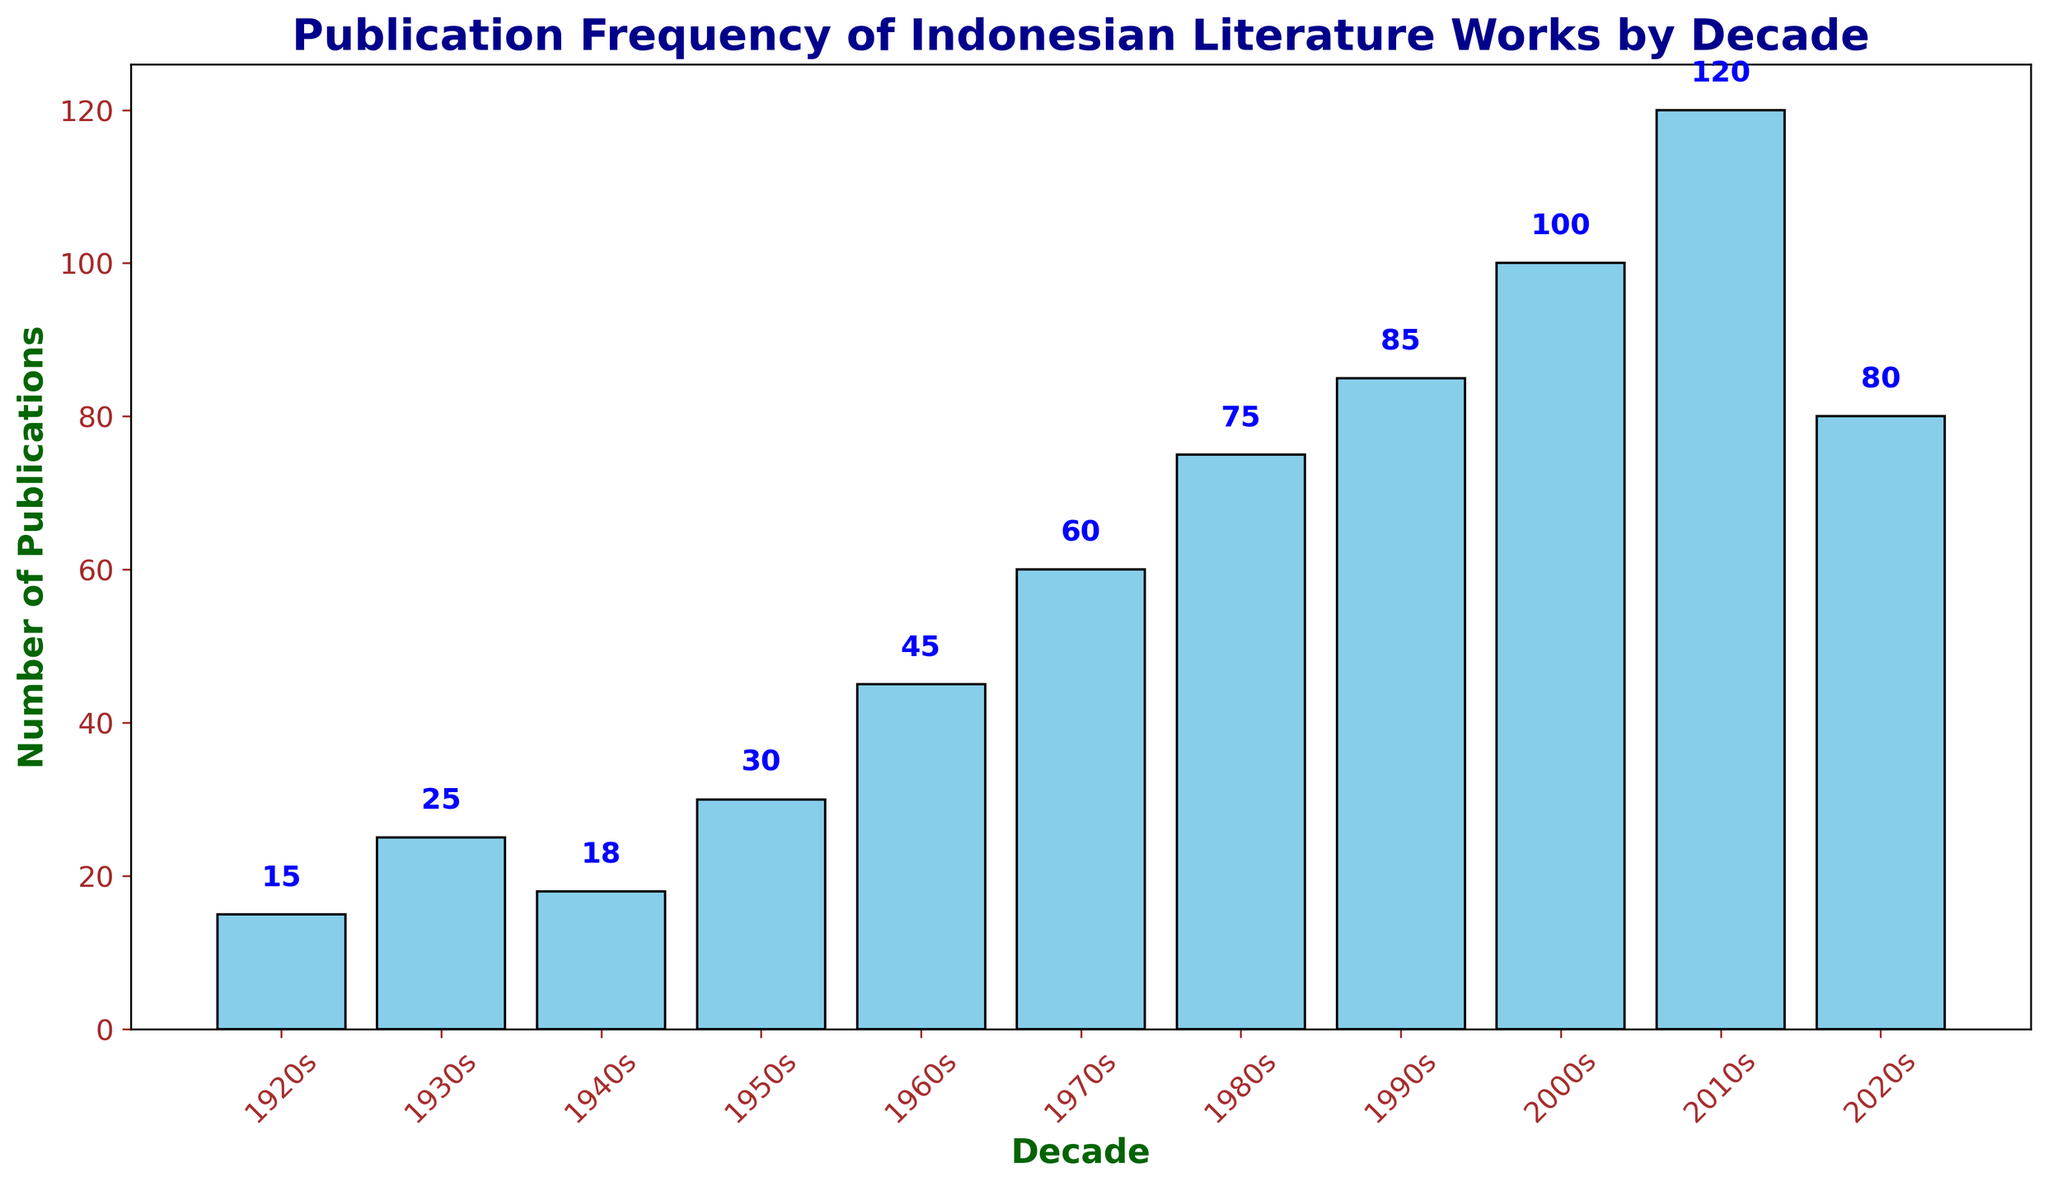What's the decade with the highest number of publications? The bar with the highest height represents the decade with the most publications, which is the 2010s at 120 publications.
Answer: 2010s Which decade experienced the greatest growth in the number of publications compared to the previous decade? By comparing the heights of the bars, the 2000s increased from 85 (1990s) to 100, and the 2010s increased from 100 (2000s) to 120. The 2000s decade had the greatest growth of 20 publications.
Answer: 2010s What is the average number of publications per decade? Summing up the number of publications from all decades and dividing by the number of decades (11). (15 + 25 + 18 + 30 + 45 + 60 + 75 + 85 + 100 + 120 + 80) / 11 = 65.45
Answer: 65.45 What is the difference in the number of publications between the 1920s and the 2020s? Subtract the number of publications in the 1920s (15) from the number in the 2020s (80). 80 - 15 = 65
Answer: 65 Which decade has the lowest number of publications? The bar with the lowest height represents the decade with the fewest publications, which is the 1920s at 15 publications.
Answer: 1920s What is the total number of publications from the 1950s to the 1980s? Adding the number of publications for each decade from the 1950s to the 1980s. (30 + 45 + 60 + 75) = 210
Answer: 210 